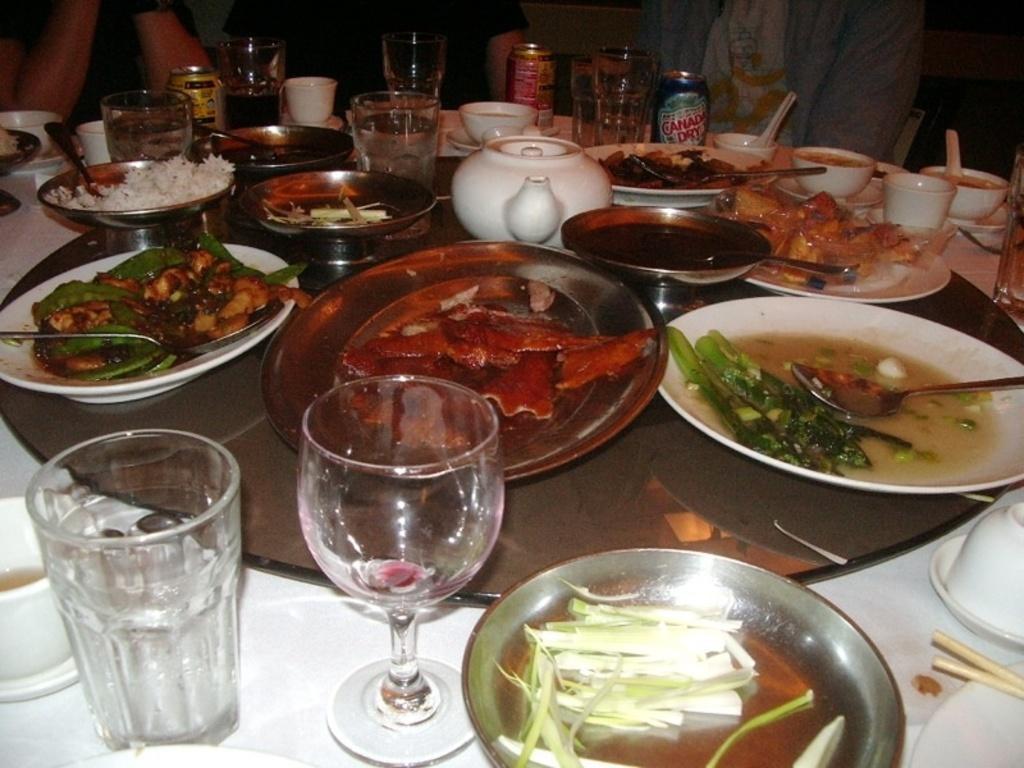Could you give a brief overview of what you see in this image? In this image in the front there is a table and on the table there are glasses, plates, and, spoons, bowls and there is food. In the center there are persons visible. 